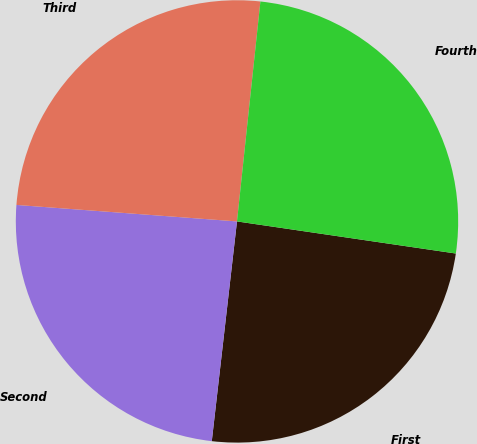Convert chart to OTSL. <chart><loc_0><loc_0><loc_500><loc_500><pie_chart><fcel>First<fcel>Second<fcel>Third<fcel>Fourth<nl><fcel>24.5%<fcel>24.37%<fcel>25.5%<fcel>25.63%<nl></chart> 